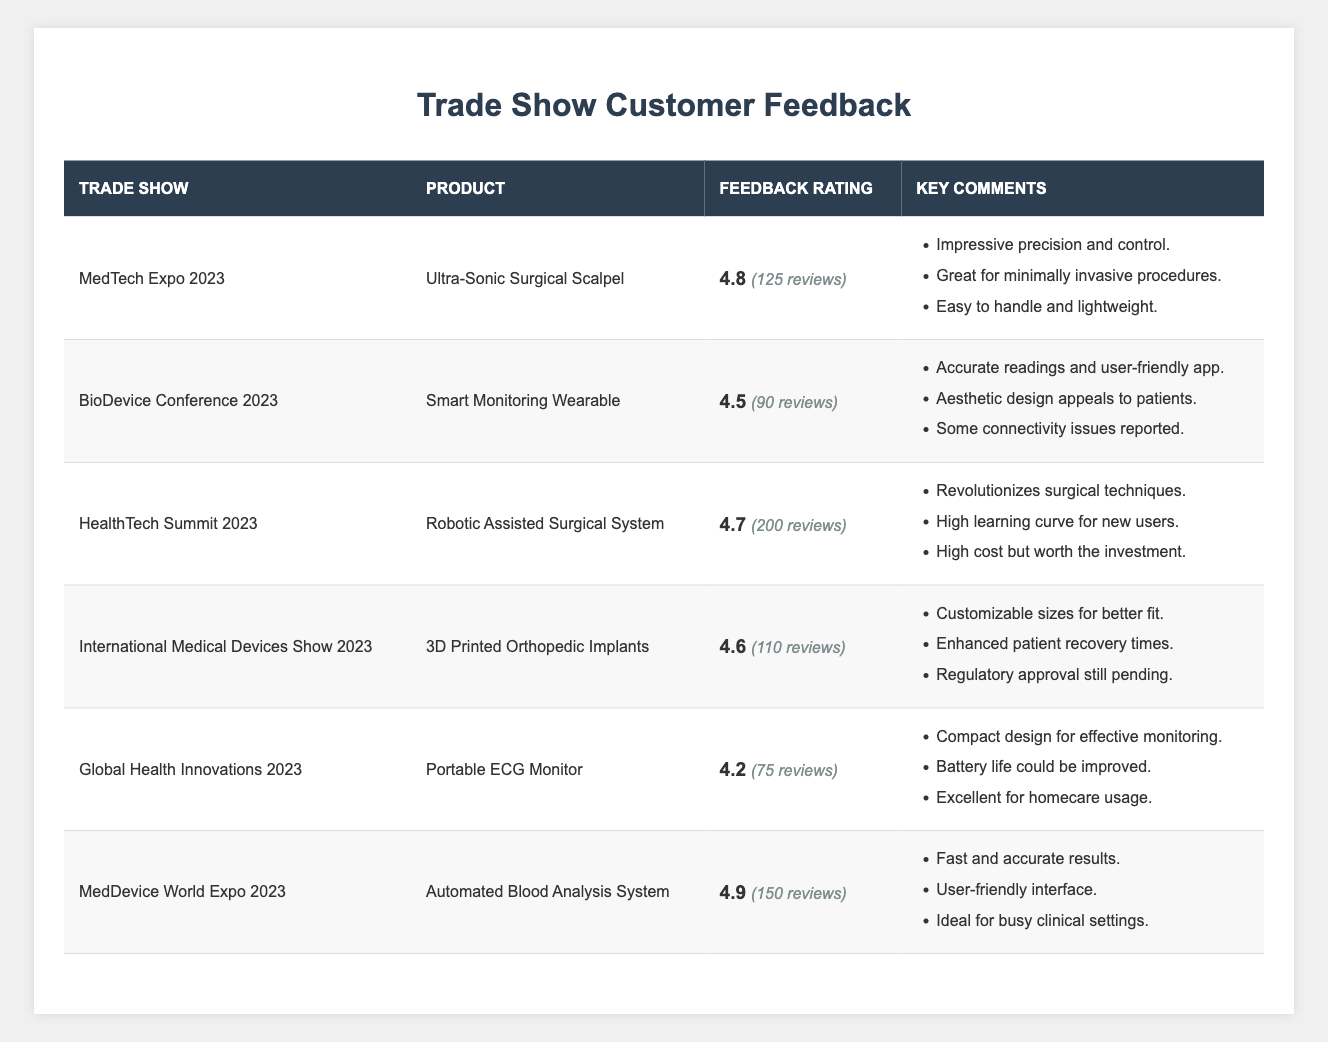What's the highest feedback rating for a product? The highest feedback rating listed in the table is for the "Automated Blood Analysis System" with a rating of 4.9 at the "MedDevice World Expo 2023".
Answer: 4.9 Which product had the most reviews? The product with the most reviews is the "Robotic Assisted Surgical System" with a total of 200 reviews listed under the "HealthTech Summit 2023".
Answer: Robotic Assisted Surgical System Did the "Portable ECG Monitor" receive a higher rating than 4.5? The "Portable ECG Monitor" received a feedback rating of 4.2, which is lower than 4.5.
Answer: No What is the average feedback rating of all products? To find the average, sum up all ratings: (4.8 + 4.5 + 4.7 + 4.6 + 4.2 + 4.9) = 28.7 and divide by the number of products (6), yielding an average of 28.7 / 6 = 4.7833.
Answer: 4.78 How many reviews were left for the "3D Printed Orthopedic Implants"? The "3D Printed Orthopedic Implants" received a total of 110 reviews at the "International Medical Devices Show 2023".
Answer: 110 Which trade show demonstrated the product with the lowest feedback rating? The product with the lowest feedback rating is the "Portable ECG Monitor" with a rating of 4.2, demonstrated at the "Global Health Innovations 2023".
Answer: Global Health Innovations 2023 What two products had feedback ratings above 4.7? The "Automated Blood Analysis System" (4.9) and the "Ultra-Sonic Surgical Scalpel" (4.8) both have ratings above 4.7.
Answer: Automated Blood Analysis System and Ultra-Sonic Surgical Scalpel Is there a product that mentions connectivity issues in the key comments? Yes, the "Smart Monitoring Wearable" mentions "Some connectivity issues reported" in its key comments.
Answer: Yes Which trade show had the least number of reviews across all products? The "Global Health Innovations 2023" had the least number of reviews with a total of 75 reviews for the "Portable ECG Monitor".
Answer: Global Health Innovations 2023 What percentage of total reviews were given to the "Automated Blood Analysis System"? The total reviews are 125 + 90 + 200 + 110 + 75 + 150 = 750. The "Automated Blood Analysis System" received 150 reviews. To find the percentage, (150 / 750) * 100 = 20%.
Answer: 20% 